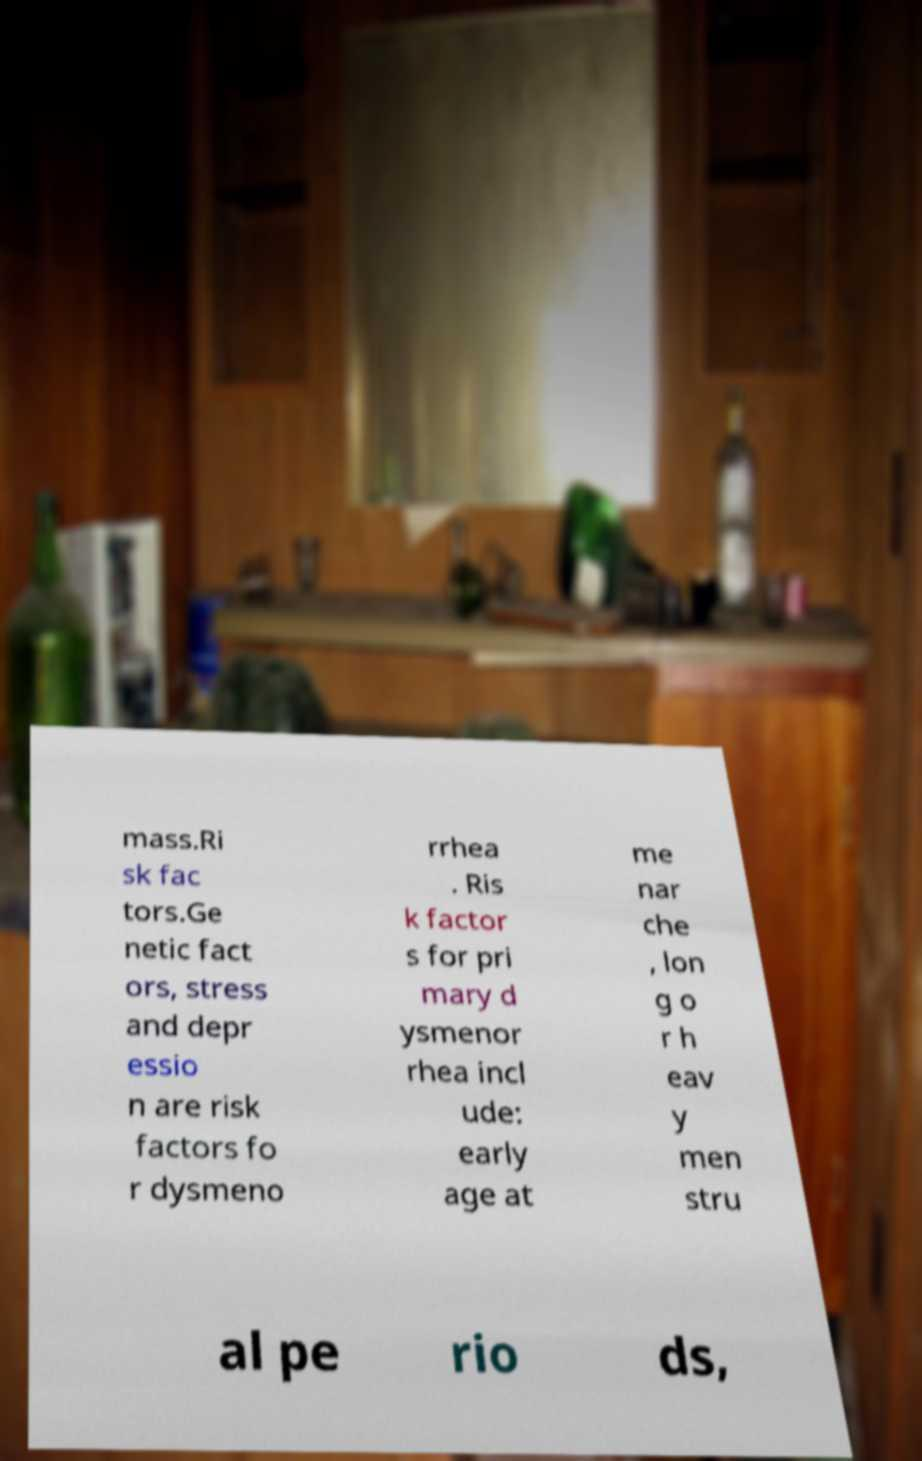Please identify and transcribe the text found in this image. mass.Ri sk fac tors.Ge netic fact ors, stress and depr essio n are risk factors fo r dysmeno rrhea . Ris k factor s for pri mary d ysmenor rhea incl ude: early age at me nar che , lon g o r h eav y men stru al pe rio ds, 